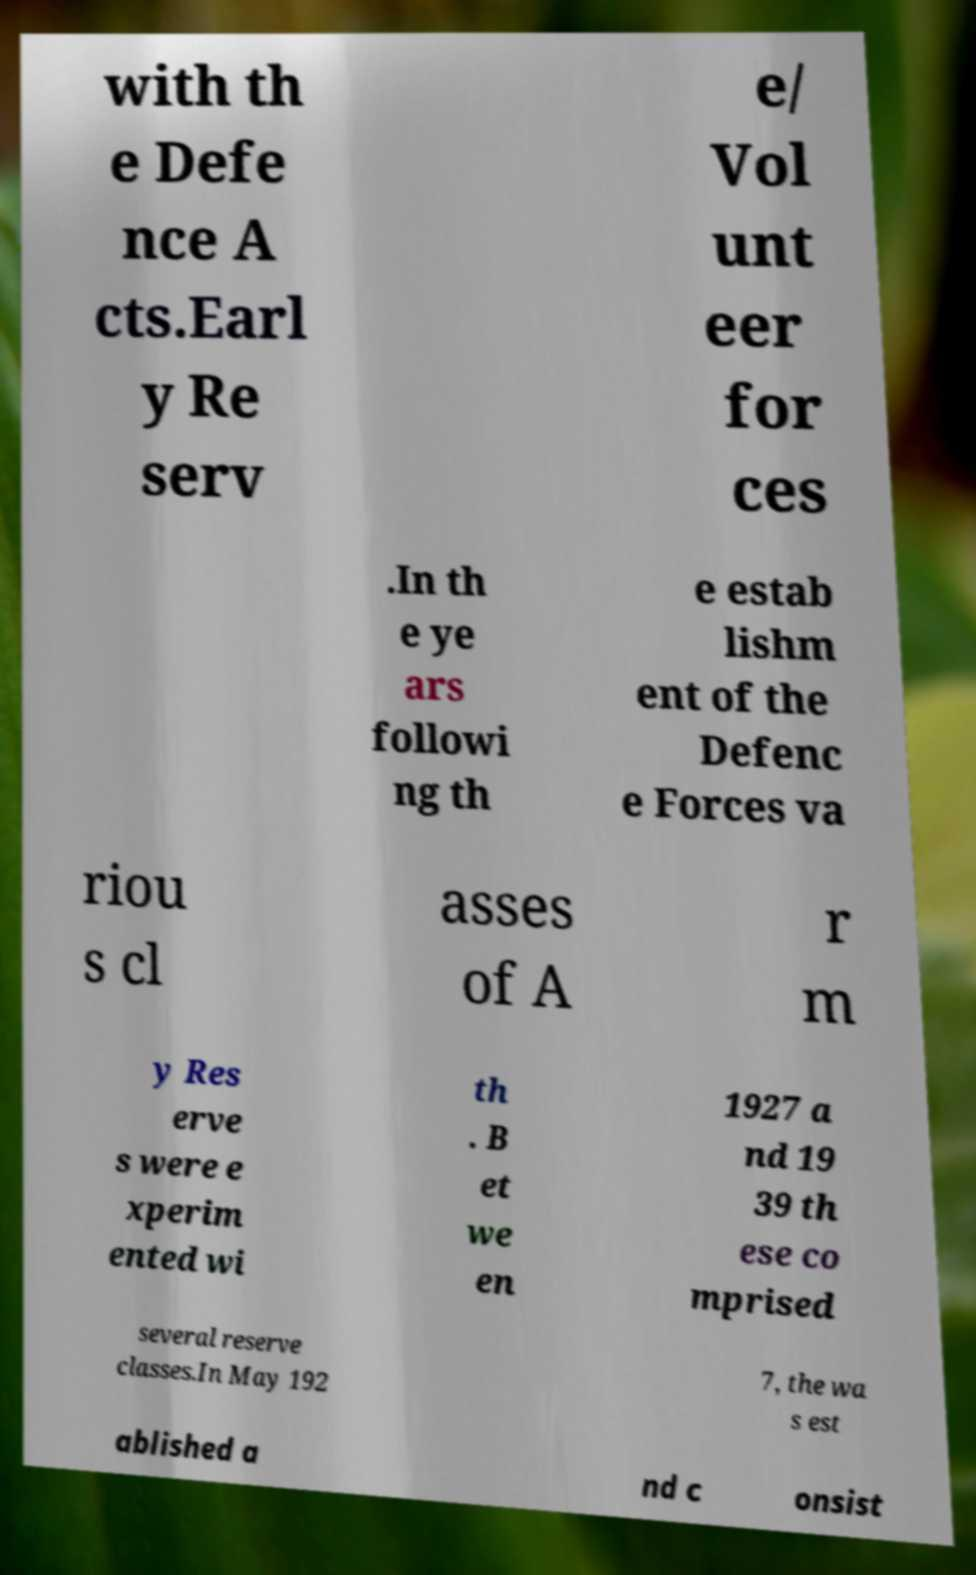Can you accurately transcribe the text from the provided image for me? with th e Defe nce A cts.Earl y Re serv e/ Vol unt eer for ces .In th e ye ars followi ng th e estab lishm ent of the Defenc e Forces va riou s cl asses of A r m y Res erve s were e xperim ented wi th . B et we en 1927 a nd 19 39 th ese co mprised several reserve classes.In May 192 7, the wa s est ablished a nd c onsist 